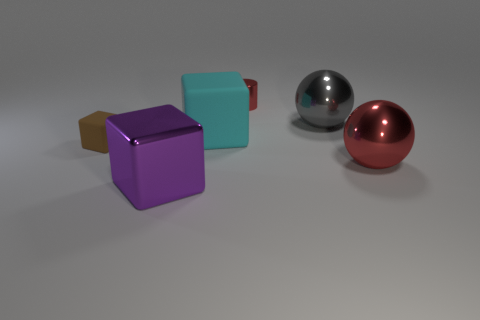Are the reflections on the smooth objects accurate representations of their surroundings? The reflective surfaces on the smooth objects provide distorted, glossy reflections that offer a stylized representation of their surroundings. They likely do not depict an accurate scene but rather show a generalized, blurred environment, suggesting modernity and simplicity. 